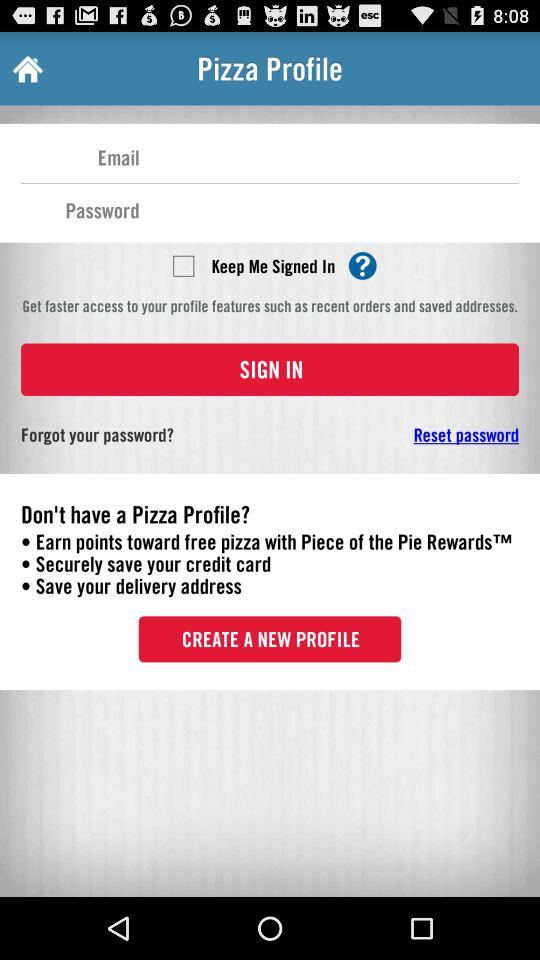What is the status of "Keep Me Signed In"? The status is "off". 